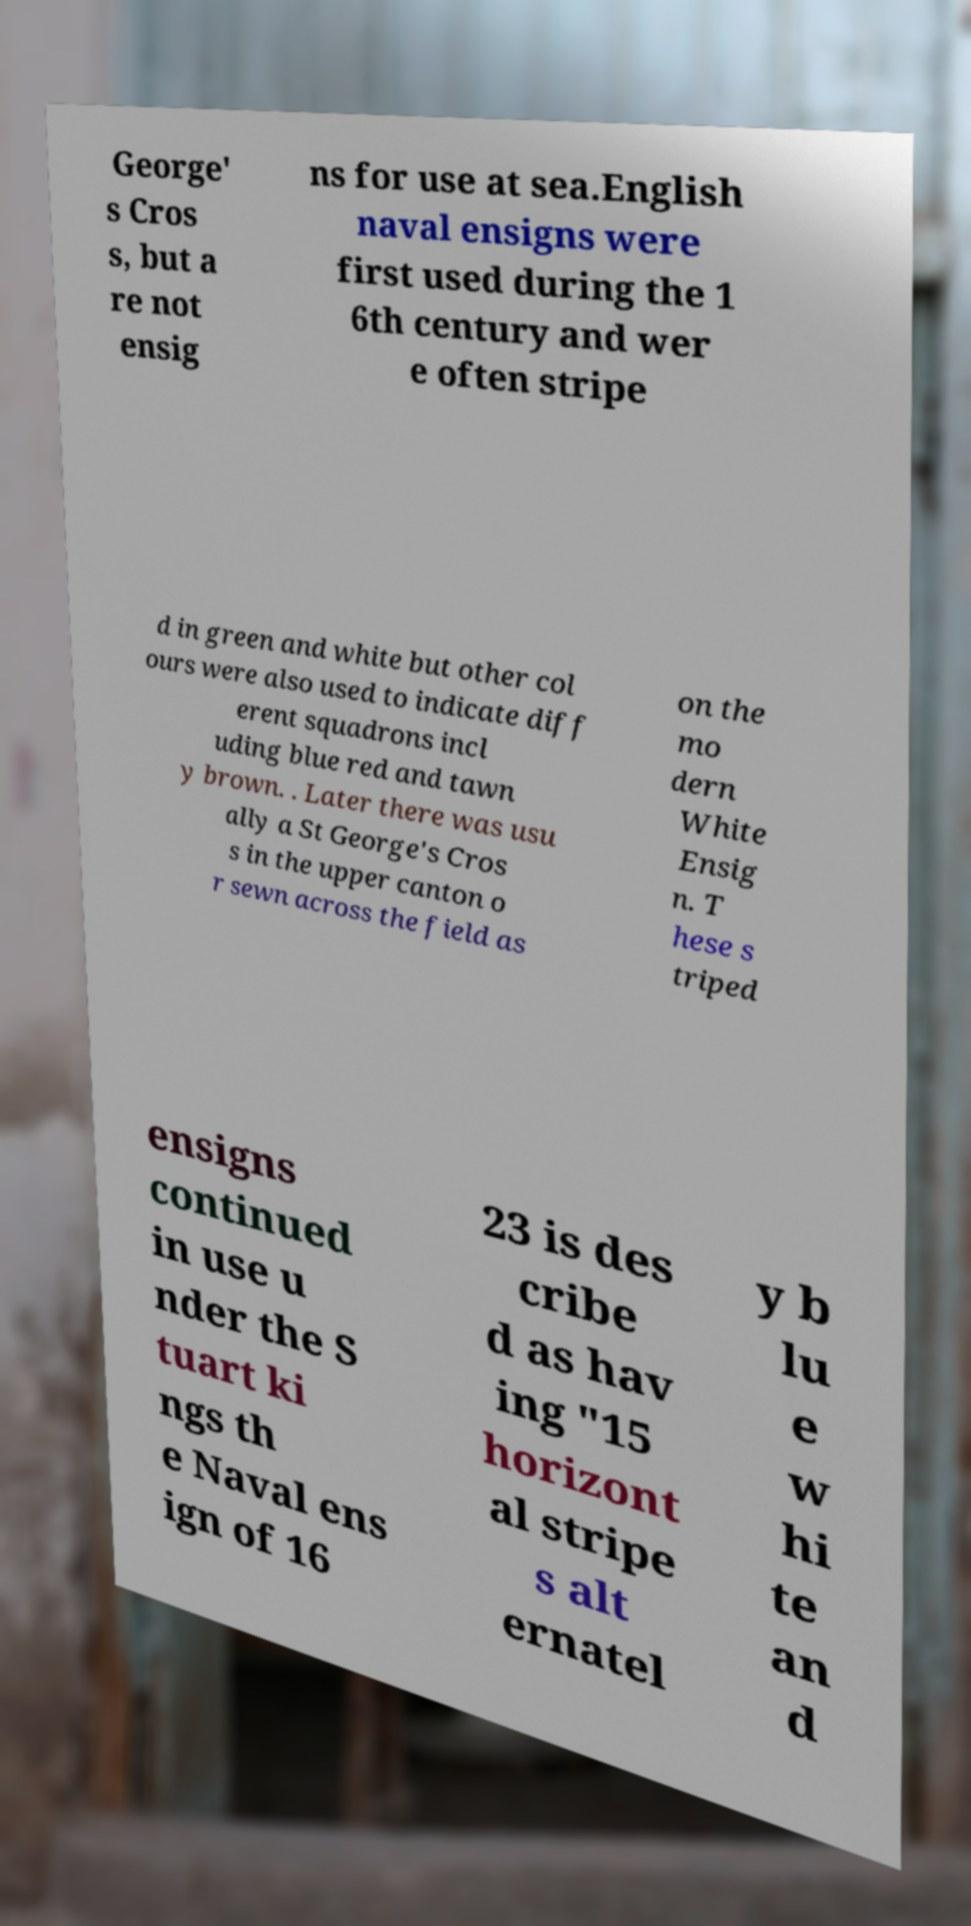I need the written content from this picture converted into text. Can you do that? George' s Cros s, but a re not ensig ns for use at sea.English naval ensigns were first used during the 1 6th century and wer e often stripe d in green and white but other col ours were also used to indicate diff erent squadrons incl uding blue red and tawn y brown. . Later there was usu ally a St George's Cros s in the upper canton o r sewn across the field as on the mo dern White Ensig n. T hese s triped ensigns continued in use u nder the S tuart ki ngs th e Naval ens ign of 16 23 is des cribe d as hav ing "15 horizont al stripe s alt ernatel y b lu e w hi te an d 